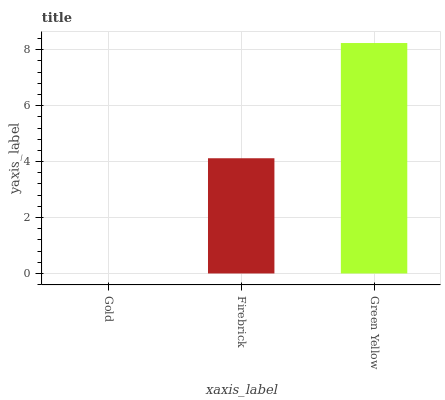Is Gold the minimum?
Answer yes or no. Yes. Is Green Yellow the maximum?
Answer yes or no. Yes. Is Firebrick the minimum?
Answer yes or no. No. Is Firebrick the maximum?
Answer yes or no. No. Is Firebrick greater than Gold?
Answer yes or no. Yes. Is Gold less than Firebrick?
Answer yes or no. Yes. Is Gold greater than Firebrick?
Answer yes or no. No. Is Firebrick less than Gold?
Answer yes or no. No. Is Firebrick the high median?
Answer yes or no. Yes. Is Firebrick the low median?
Answer yes or no. Yes. Is Green Yellow the high median?
Answer yes or no. No. Is Green Yellow the low median?
Answer yes or no. No. 